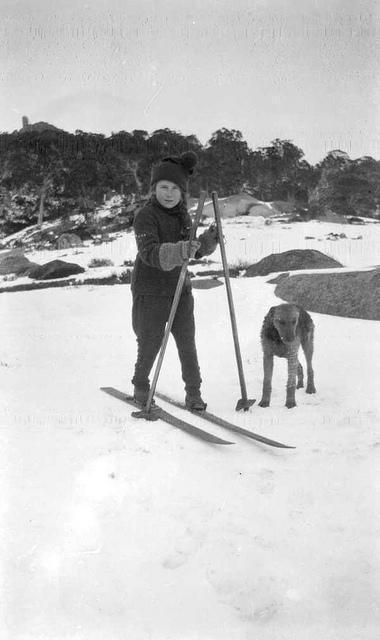How many canines are in the photo?
Give a very brief answer. 1. How many dogs are in the photo?
Give a very brief answer. 1. How many dogs are there?
Give a very brief answer. 1. How many water bottles are in the picture?
Give a very brief answer. 0. 